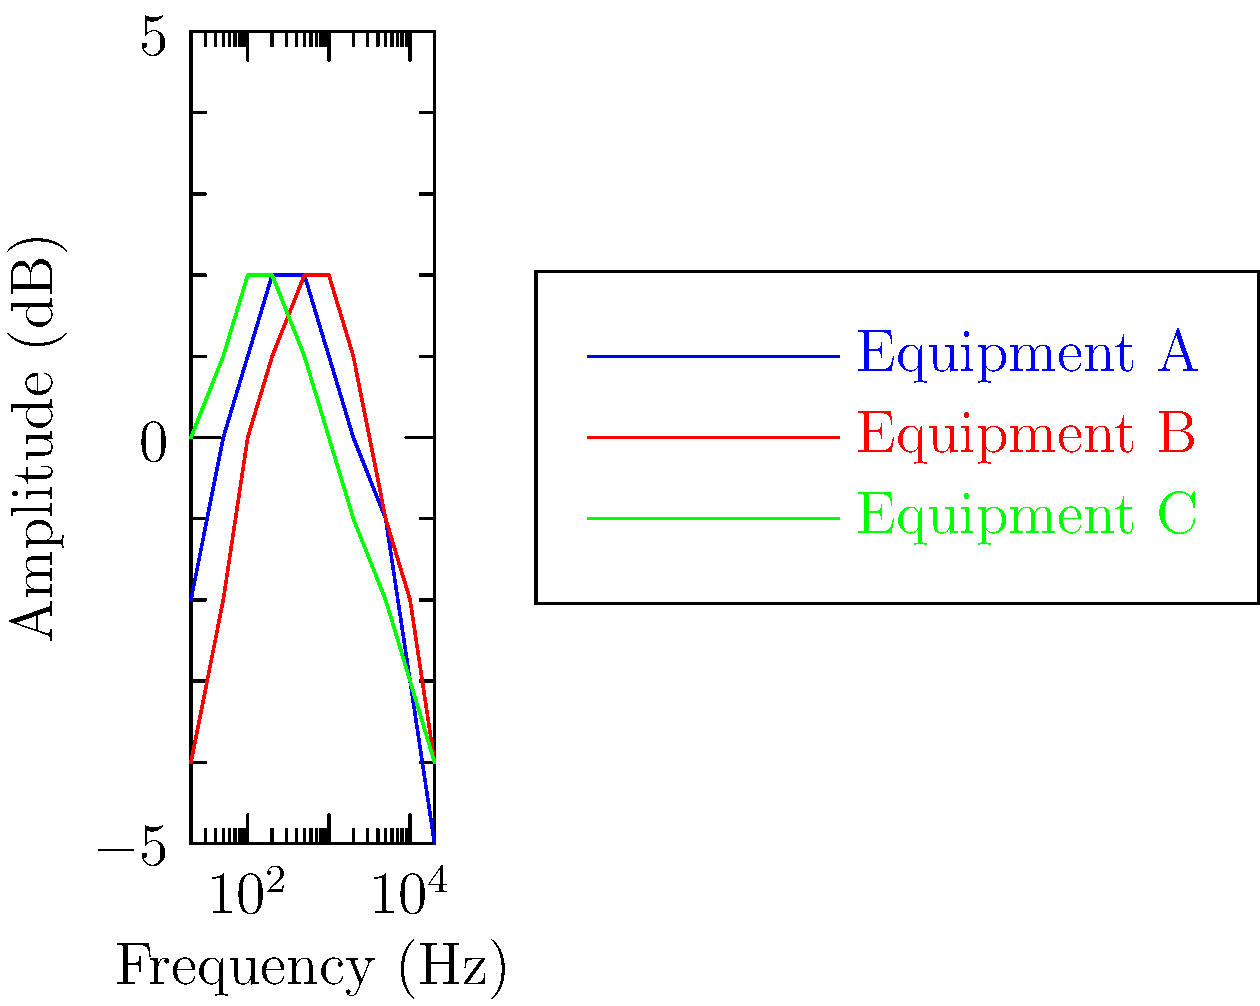As a music producer, you're comparing the frequency response of three different pieces of audio equipment. Based on the graph, which equipment would be best suited for capturing and reproducing low-frequency sounds (bass) with the most accuracy? To determine which equipment is best suited for capturing and reproducing low-frequency sounds (bass) with the most accuracy, we need to analyze the graph for each piece of equipment in the low-frequency range (typically below 250 Hz). Let's break it down step-by-step:

1. Identify the low-frequency range: On the graph, this would be roughly from 20 Hz to 250 Hz.

2. Analyze each equipment's response in this range:

   Equipment A (blue line):
   - Starts at -2 dB at 20 Hz
   - Rises to 0 dB at 50 Hz
   - Continues to rise to +2 dB at 200 Hz

   Equipment B (red line):
   - Starts at -4 dB at 20 Hz
   - Rises to -2 dB at 50 Hz
   - Continues to rise to +1 dB at 200 Hz

   Equipment C (green line):
   - Starts at 0 dB at 20 Hz
   - Rises to +1 dB at 50 Hz
   - Peaks at +2 dB around 100-200 Hz

3. Consider the ideal response: For accurate reproduction, we want a response that is as flat as possible in the desired frequency range.

4. Compare the responses:
   - Equipment A has a significant boost in the low end, which may color the sound.
   - Equipment B has a pronounced dip in the very low frequencies, which may result in weak bass reproduction.
   - Equipment C has the flattest response in the low-frequency range, with only a slight boost.

5. Conclusion: Equipment C (green line) provides the most accurate representation of low-frequency sounds, as it has the flattest response in the bass range with only a slight emphasis, which can be beneficial for bass reproduction without overemphasizing it.
Answer: Equipment C 